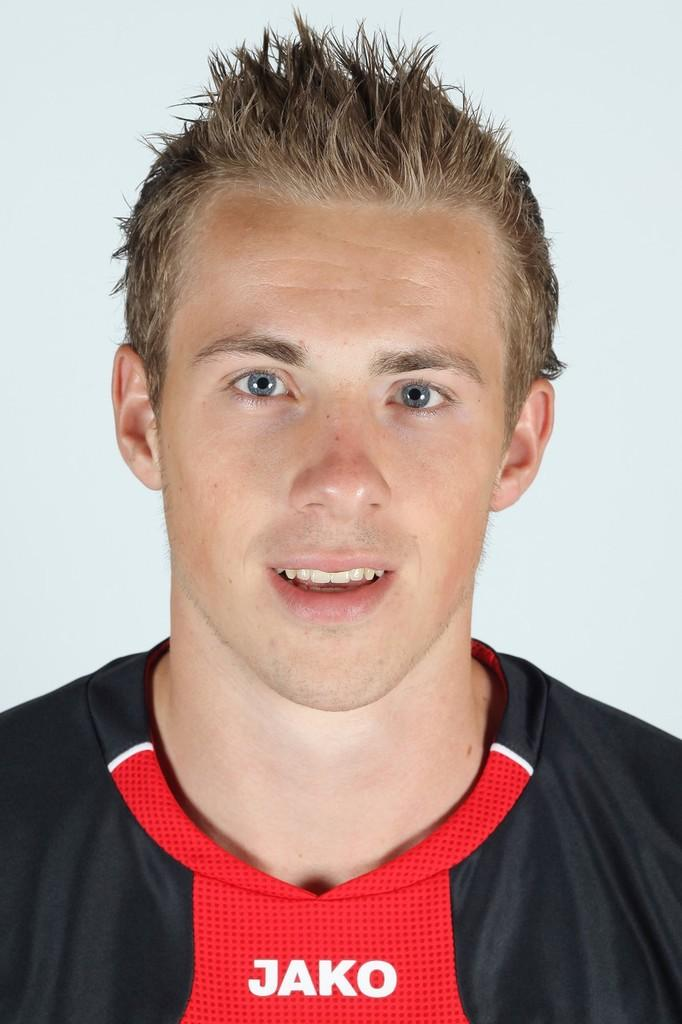<image>
Give a short and clear explanation of the subsequent image. a boy wearing a top with the word Jako on the front 